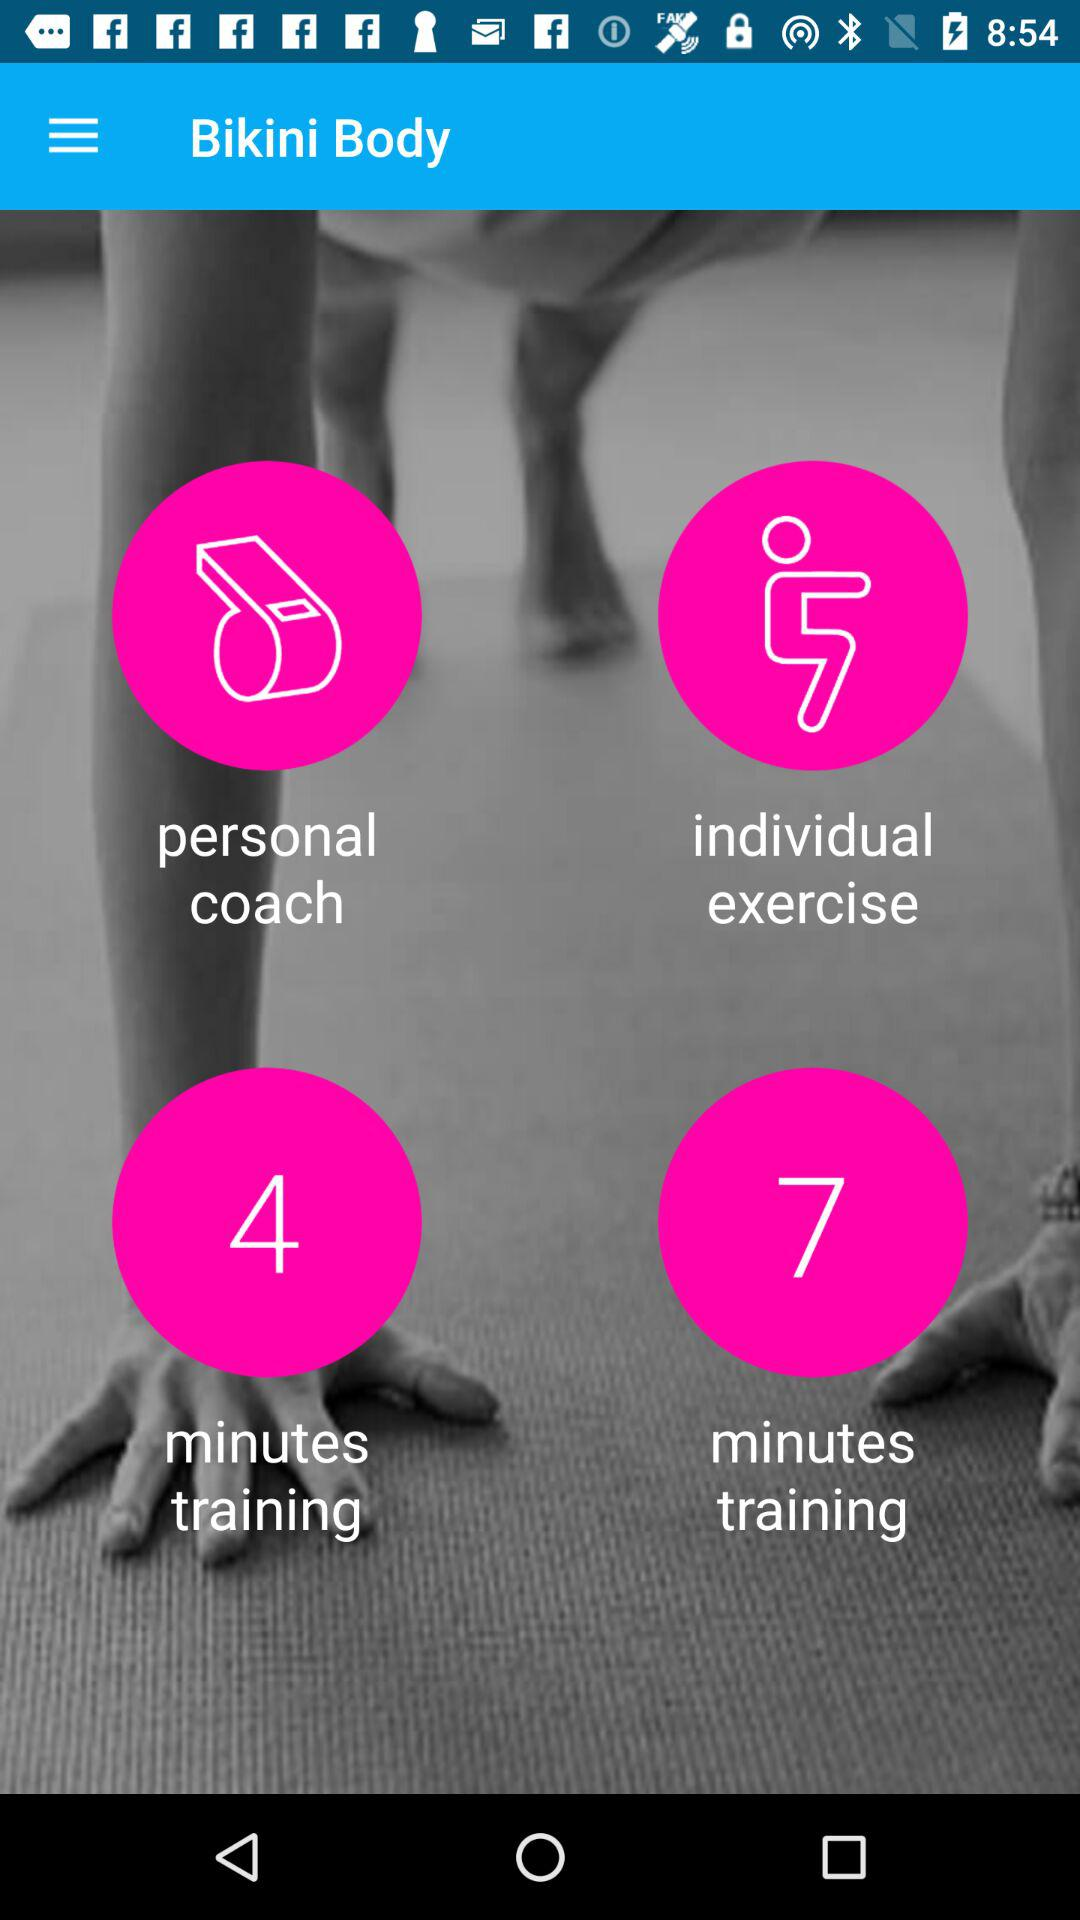How many more minutes of training are there for the individual exercise than for the personal coach?
Answer the question using a single word or phrase. 3 